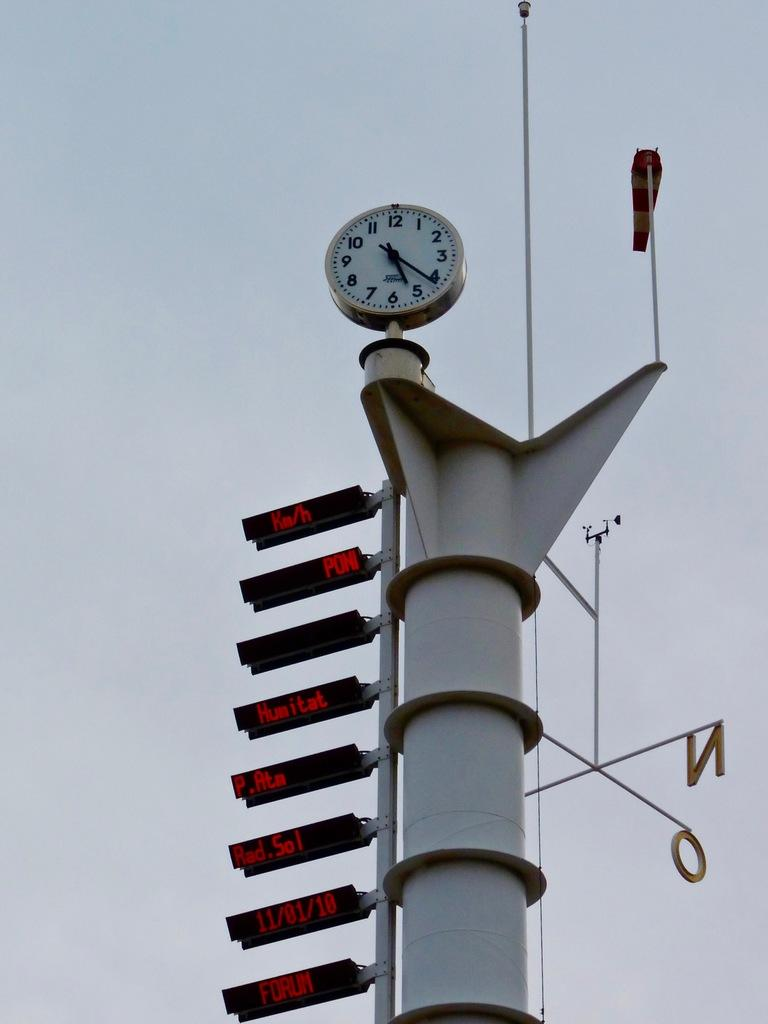What object in the picture displays the time? There is a clock in the picture that displays the time. What feature does the clock have? The clock has numbers. What can be used to provide directions in the picture? There is a direction board in the picture. What type of display devices are in the picture? There are screens in the picture. What tall structure is visible in the picture? There is a tower in the picture. What type of insurance policy is being advertised on the tower in the image? There is no advertisement or mention of insurance in the image; the tower is a standalone structure. How many people are running in the picture? There is no indication of people running in the image; the focus is on the clock, direction board, screens, and tower. 